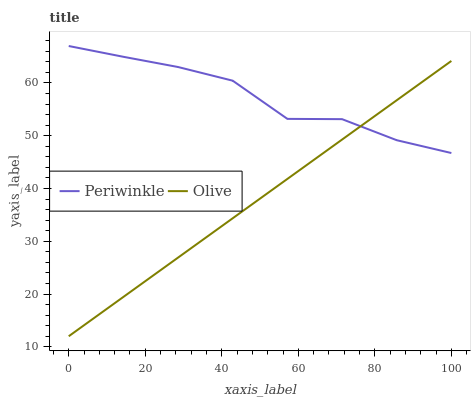Does Olive have the minimum area under the curve?
Answer yes or no. Yes. Does Periwinkle have the maximum area under the curve?
Answer yes or no. Yes. Does Periwinkle have the minimum area under the curve?
Answer yes or no. No. Is Olive the smoothest?
Answer yes or no. Yes. Is Periwinkle the roughest?
Answer yes or no. Yes. Is Periwinkle the smoothest?
Answer yes or no. No. Does Olive have the lowest value?
Answer yes or no. Yes. Does Periwinkle have the lowest value?
Answer yes or no. No. Does Periwinkle have the highest value?
Answer yes or no. Yes. Does Olive intersect Periwinkle?
Answer yes or no. Yes. Is Olive less than Periwinkle?
Answer yes or no. No. Is Olive greater than Periwinkle?
Answer yes or no. No. 